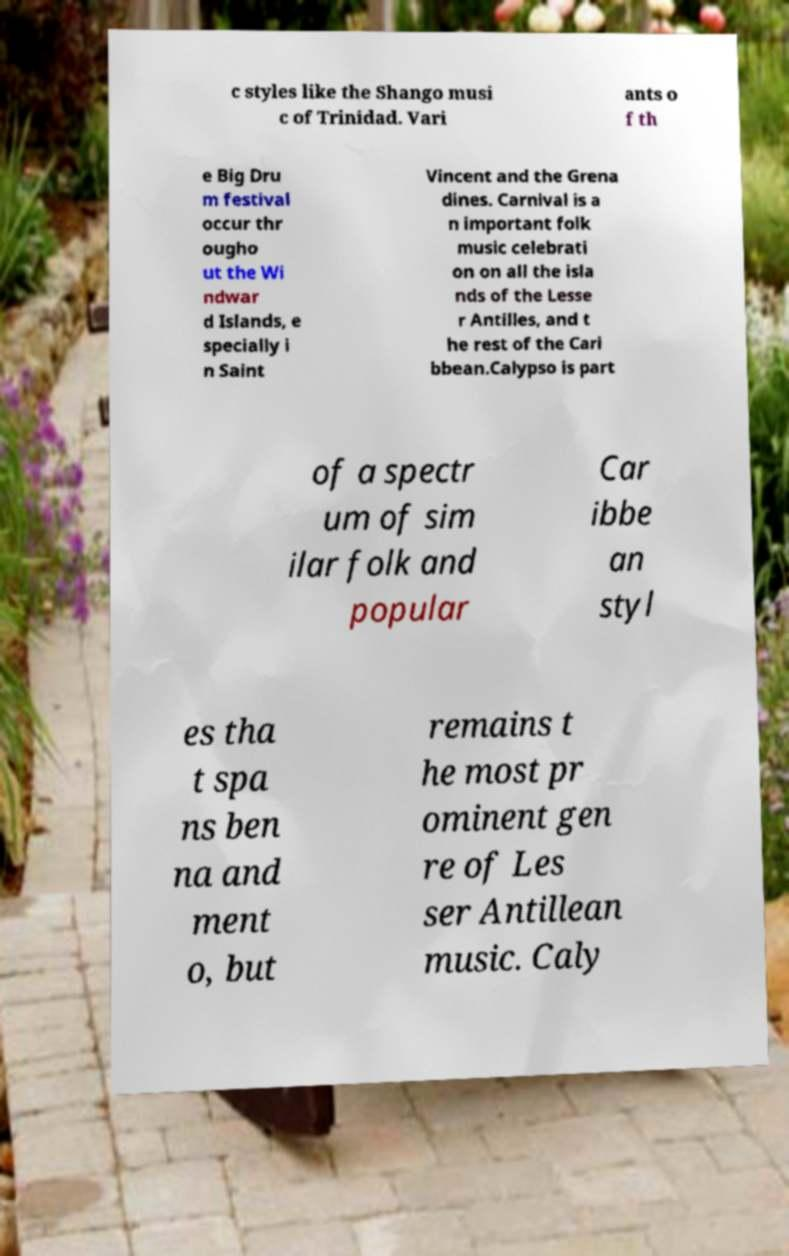Could you assist in decoding the text presented in this image and type it out clearly? c styles like the Shango musi c of Trinidad. Vari ants o f th e Big Dru m festival occur thr ougho ut the Wi ndwar d Islands, e specially i n Saint Vincent and the Grena dines. Carnival is a n important folk music celebrati on on all the isla nds of the Lesse r Antilles, and t he rest of the Cari bbean.Calypso is part of a spectr um of sim ilar folk and popular Car ibbe an styl es tha t spa ns ben na and ment o, but remains t he most pr ominent gen re of Les ser Antillean music. Caly 